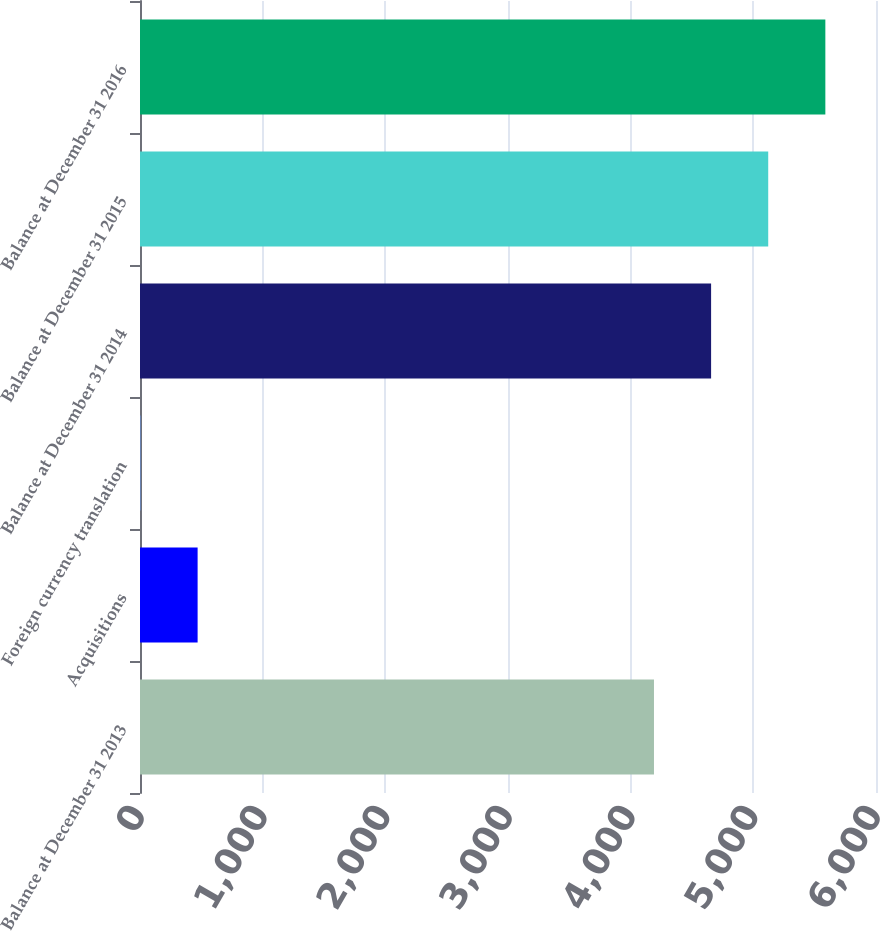<chart> <loc_0><loc_0><loc_500><loc_500><bar_chart><fcel>Balance at December 31 2013<fcel>Acquisitions<fcel>Foreign currency translation<fcel>Balance at December 31 2014<fcel>Balance at December 31 2015<fcel>Balance at December 31 2016<nl><fcel>4190<fcel>469.7<fcel>4<fcel>4655.7<fcel>5121.4<fcel>5587.1<nl></chart> 